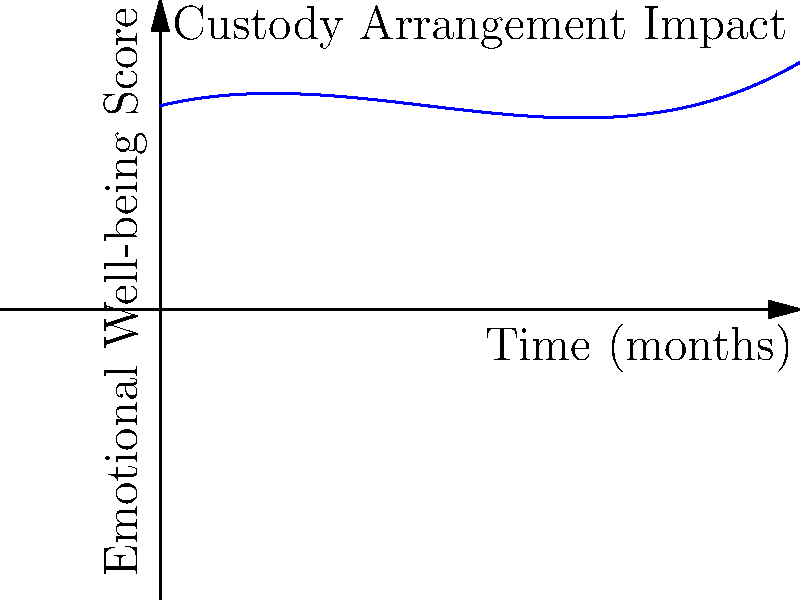Using the polynomial regression model shown in the graph, which represents the predicted emotional well-being of a child over time based on custody arrangements, at what point (in months) does the child's emotional well-being score reach its minimum? How can this information be used to justify a change in custody arrangements? To find the minimum point of the polynomial function, we need to follow these steps:

1. The given polynomial function is of the form:
   $$f(x) = 0.1x^3 - 1.5x^2 + 5x + 80$$

2. To find the minimum, we need to find where the derivative equals zero:
   $$f'(x) = 0.3x^2 - 3x + 5$$

3. Set the derivative to zero and solve:
   $$0.3x^2 - 3x + 5 = 0$$

4. This is a quadratic equation. We can solve it using the quadratic formula:
   $$x = \frac{-b \pm \sqrt{b^2 - 4ac}}{2a}$$
   where $a = 0.3$, $b = -3$, and $c = 5$

5. Solving this equation gives us:
   $$x \approx 5.77$$ or $$x \approx 2.89$$

6. The second solution (2.89) is the minimum point, as it corresponds to the lowest point on the graph.

7. This means the child's emotional well-being reaches its lowest point after approximately 2.89 months.

To use this information to justify a change in custody arrangements, one could argue that the current arrangement leads to a significant drop in the child's emotional well-being in the short term. By modifying the custody arrangement, it may be possible to avoid this dip and maintain a higher level of emotional well-being for the child.
Answer: 2.89 months; argue current arrangement causes short-term emotional decline 